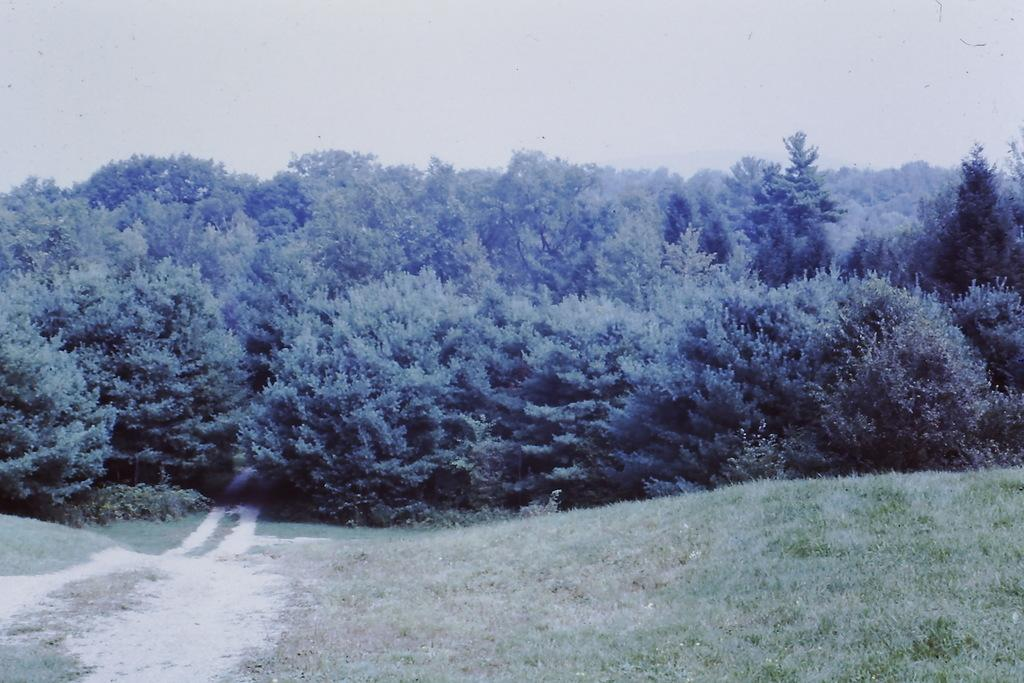Where was the image taken? The image was clicked outside the city. What type of vegetation is present at the bottom of the image? There is green grass on the ground at the bottom of the image. What can be seen in the background of the image? There are many trees in the background of the image. What is visible at the top of the image? The sky is visible at the top of the image. What type of punishment is being handed out to the squirrel in the image? There is no squirrel present in the image, and therefore no punishment is being handed out. 